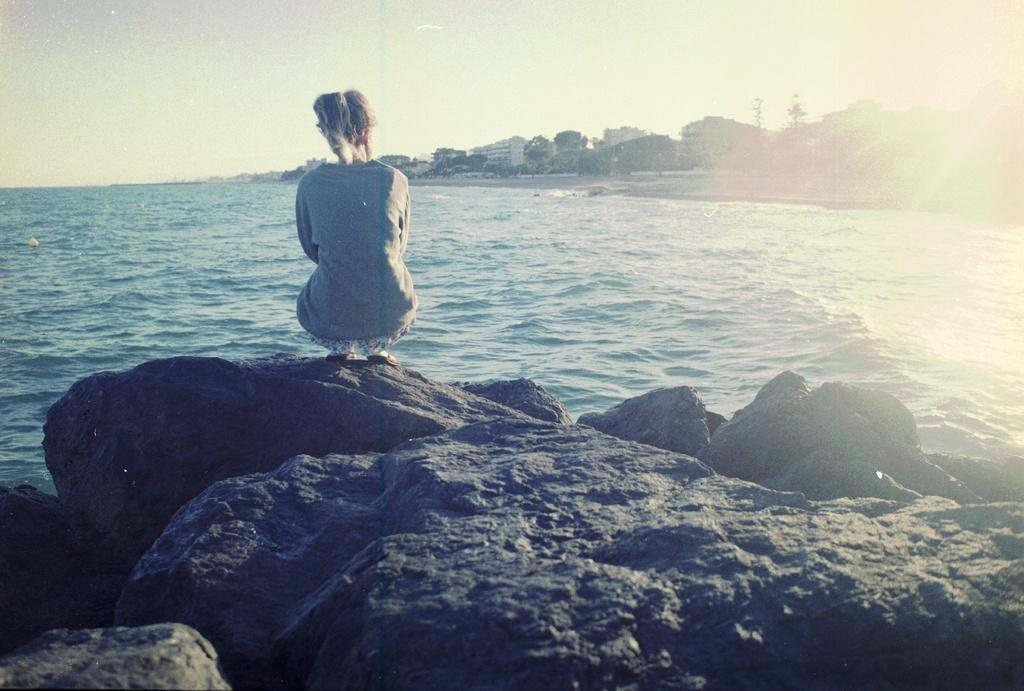Who is present in the image? There is a woman in the image. What position is the woman in? The woman is sitting in a squat position. What type of natural elements can be seen in the image? There are rocks and water visible in the image. What can be seen in the background of the image? There are buildings, trees, and the sky visible in the background of the image. What unit of measurement is the woman using to copy the rocks in the image? There is no indication in the image that the woman is copying the rocks or using any unit of measurement. 